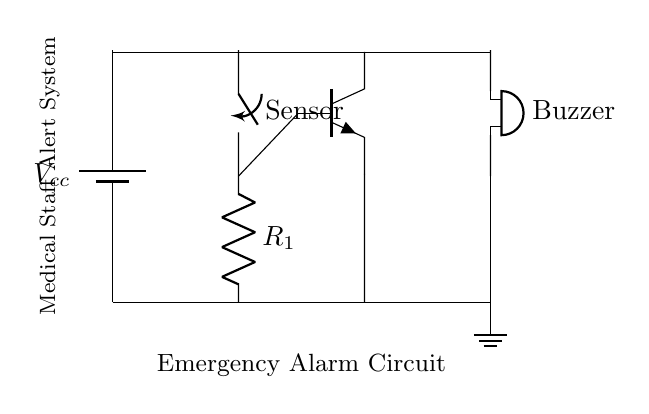What is the power supply voltage in this circuit? The circuit includes a battery labeled as Vcc, which typically indicates the power supply voltage used for the circuit. The actual voltage value is not specified in the diagram, but it's commonly assumed to be a standard like 5V or 9V.
Answer: Vcc What type of switch is used in this circuit? The circuit diagram shows a component labeled "Sensor" which is identified as a switch, indicating its function to control the current flow based on external conditions, such as the detection of an emergency.
Answer: Switch What is the role of the transistor in this circuit? The transistor (identified as NPN) acts as a switch or amplifier in the circuit, allowing control of a larger current (to the buzzer) from a smaller current (from the sensor), ensuring the alarm can trigger effectively upon detection of an emergency.
Answer: Amplifier How many resistors are present in this circuit? By examining the diagram, there is one component labeled "R1" which identifies it as the sole resistor present in the circuit, providing current limiting or voltage dropping functions as needed in transistor operations.
Answer: One What component is used to provide the alarm signal? The buzzer is explicitly labeled in the circuit diagram, and it serves as the component that produces sound to alert medical staff in an emergency situation when triggered by the transistor.
Answer: Buzzer What happens when the sensor is activated? When the sensor (switch) is closed (activated), it allows current to flow through R1 to the base of the NPN transistor, turning it on, which in turn enables greater current to flow to the buzzer, activating the alarm signal.
Answer: Alarm triggers 